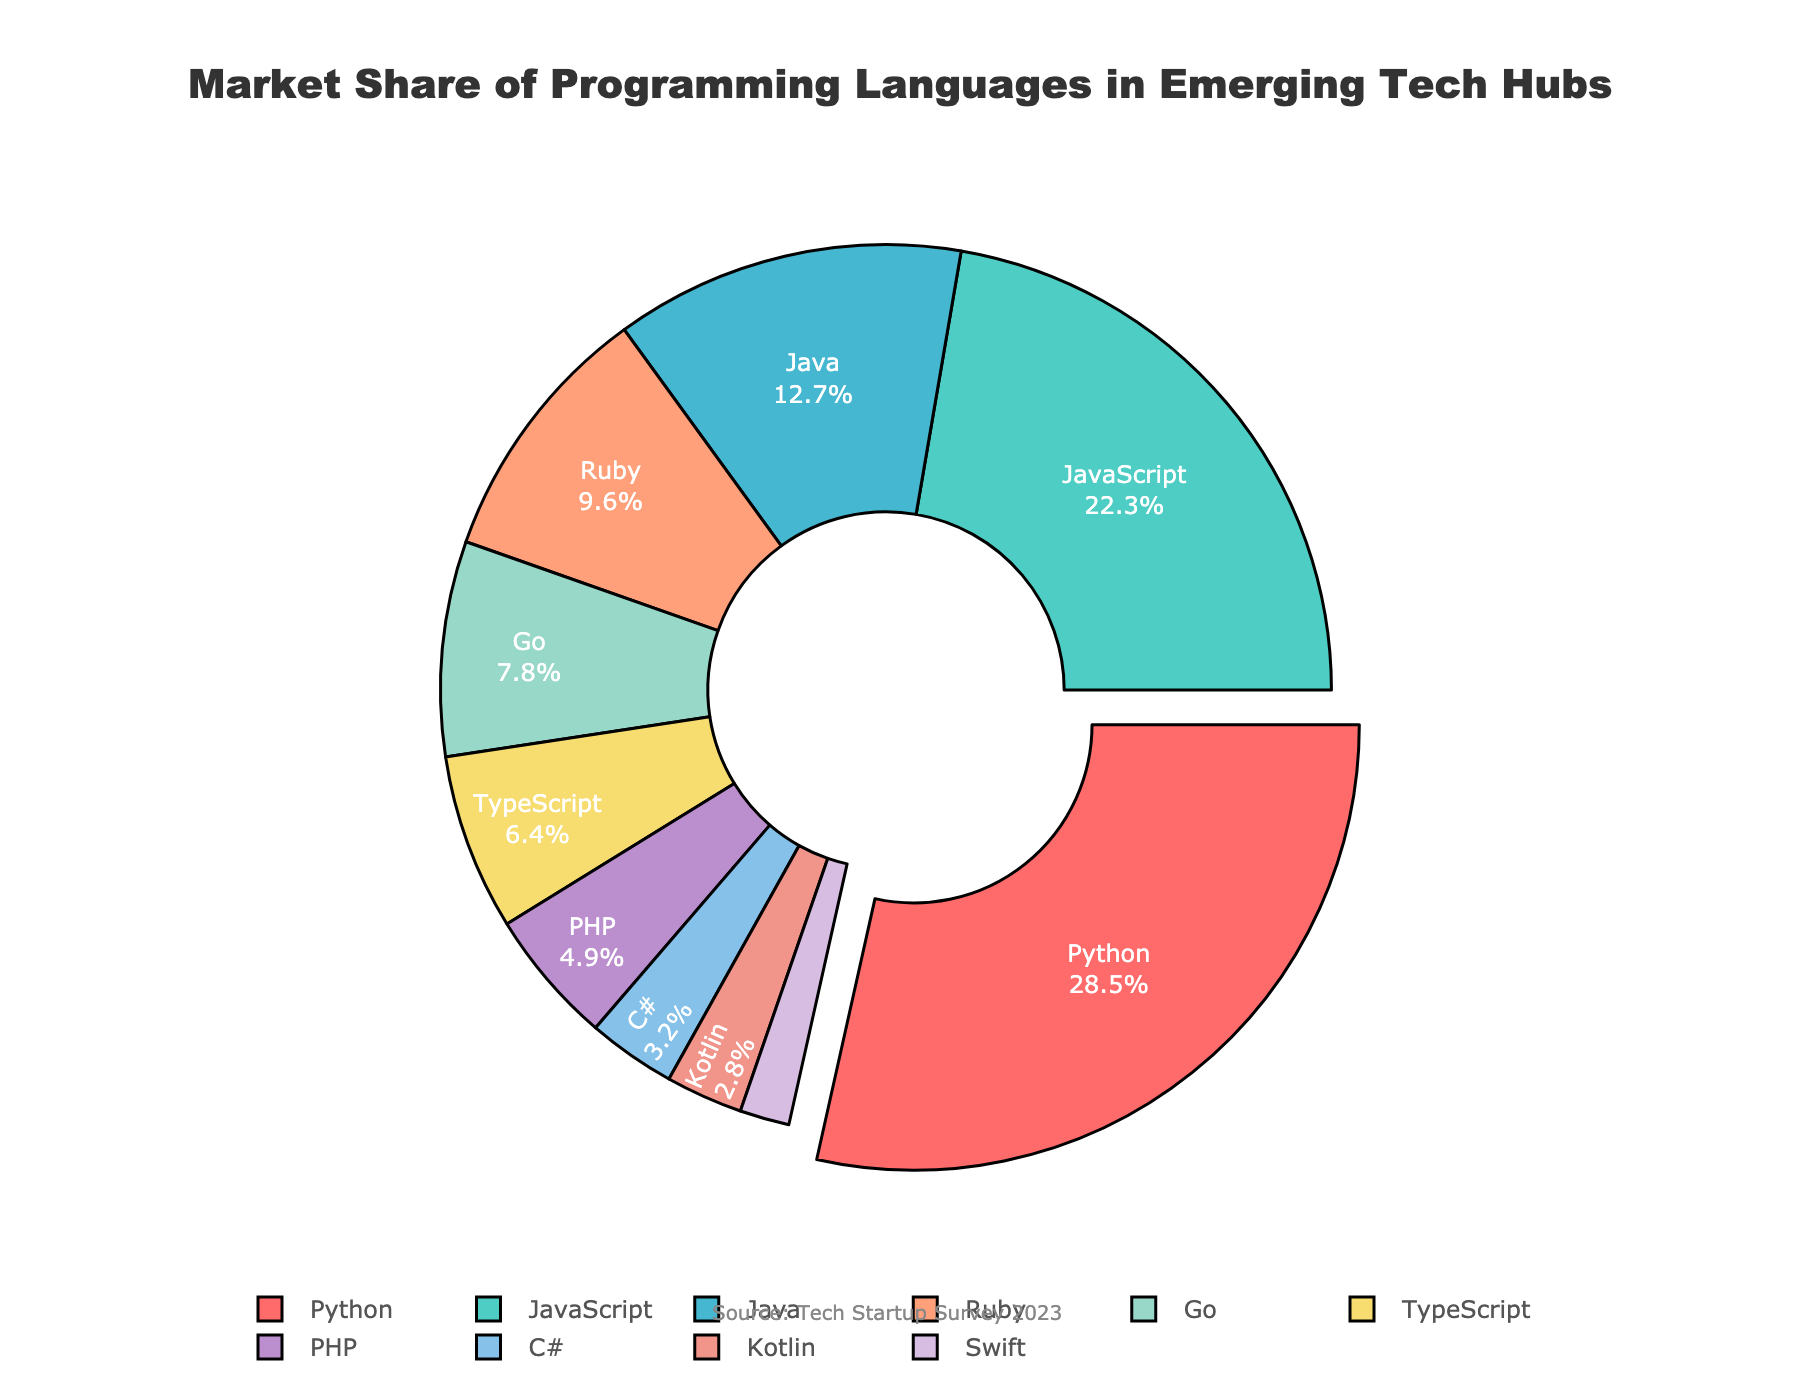Which programming language has the largest market share? The pie chart shows the market share of different programming languages, with the largest section pulled out for emphasis. Python occupies the largest section.
Answer: Python What percentage of the market share does Swift have? From the pie chart, Swift's slice is labeled with its corresponding percentage value.
Answer: 1.8% How much larger is Python's market share compared to Java? Python's market share is noted as 28.5%, and Java's is 12.7%. Subtract Java's percentage from Python's to find the difference. 28.5% - 12.7% = 15.8%
Answer: 15.8% Which programming languages have a market share greater than 10%? The sections of the pie chart labeled 'Python', 'JavaScript', and 'Java' each have percentages greater than 10%.
Answer: Python, JavaScript, Java What is the combined market share of Go, TypeScript, and PHP? Sum the percentages for Go (7.8%), TypeScript (6.4%), and PHP (4.9%). 7.8% + 6.4% + 4.9% = 19.1%
Answer: 19.1% Is TypeScript's market share larger or smaller than Ruby's? Compare the percentages directly from the pie chart: TypeScript (6.4%) vs Ruby (9.6%).
Answer: Smaller Which programming language has a market share closest to 5%? Review the percentages on the chart. PHP has a market share of 4.9%, which is the closest to 5%.
Answer: PHP How many programming languages shown have a market share below 5%? Look at the labels with percentages directly from the pie chart: PHP (4.9%), C# (3.2%), Kotlin (2.8%), and Swift (1.8%) are below 5%.
Answer: Four What are the two least popular programming languages according to the market share? Identify the two smallest slices of the pie chart. They are Swift (1.8%) and Kotlin (2.8%).
Answer: Swift, Kotlin Which color represents Java on the pie chart? Based on the visual cues from the chart, find the segment labeled Java and note its color.
Answer: This requires observation of the specific chart colors shown but is not specified here 